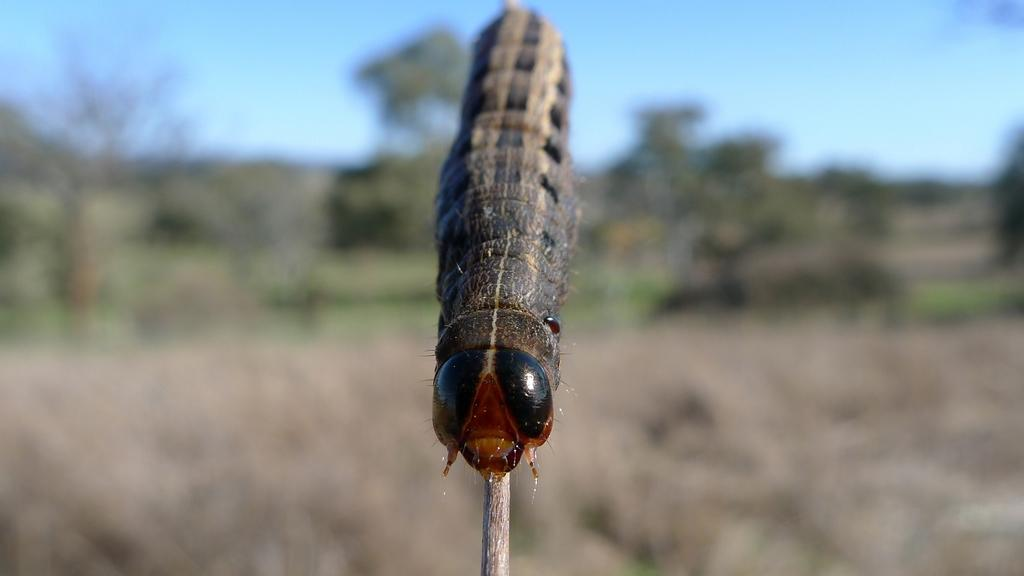What is the main subject of the image? There is an insect on a stick in the image. What can be seen in the background of the image? There are trees in the background of the image. What is visible at the top of the image? The sky is visible at the top of the image. What religious book is the insect holding in the image? There is no religious book present in the image; it features an insect on a stick with trees in the background and the sky visible at the top. 